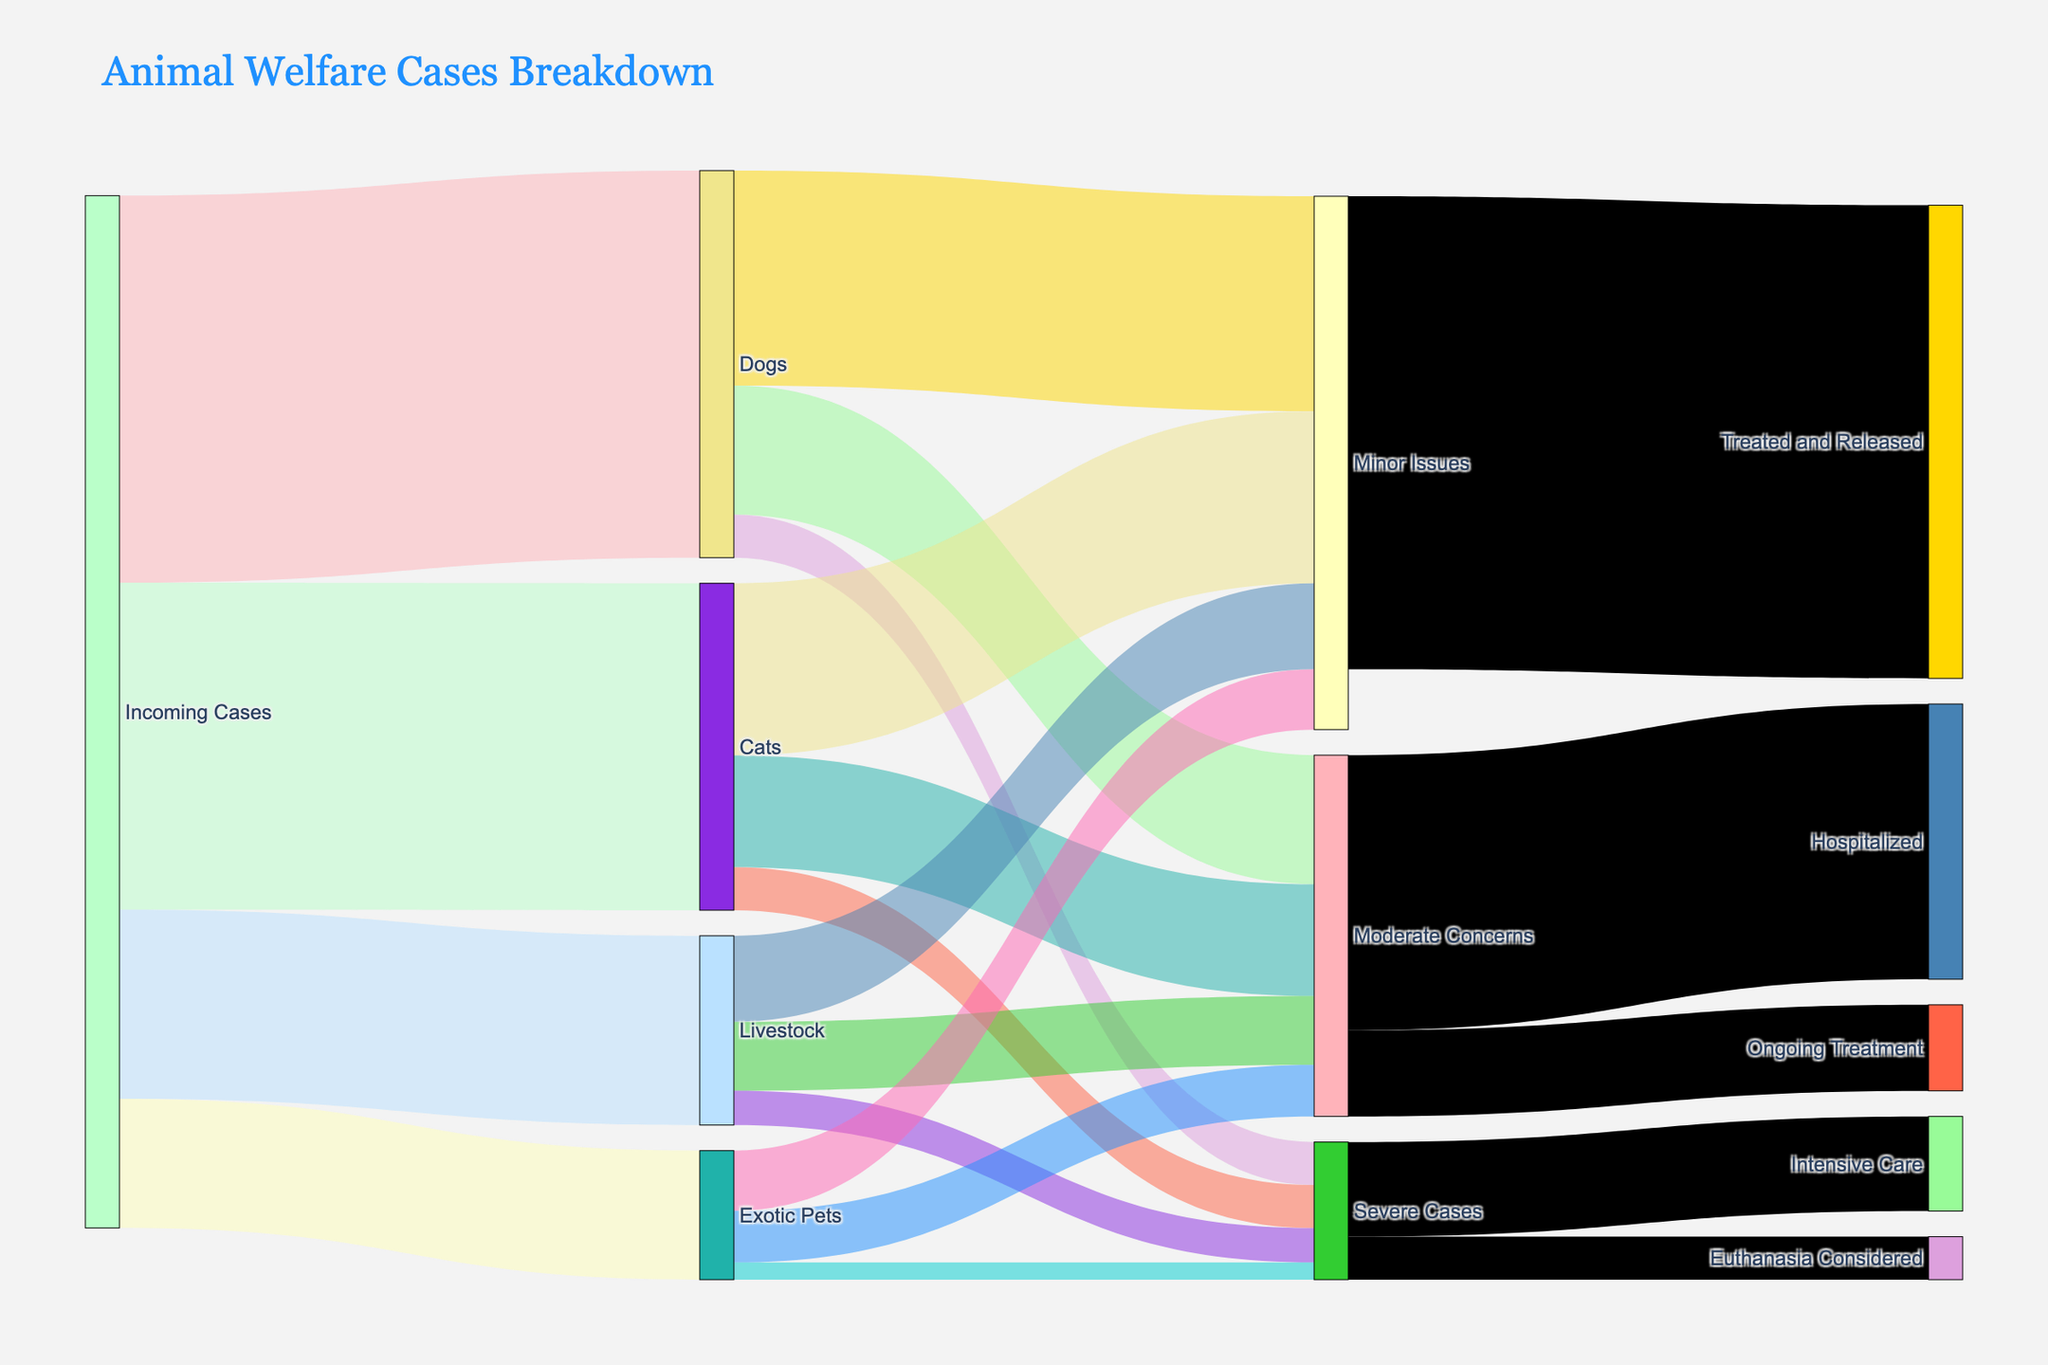How many incoming cases of dogs were handled by the veterinary clinic? To find the number of incoming cases of dogs, we look for the link connecting "Incoming Cases" to "Dogs" in the diagram, which shows a value of 450.
Answer: 450 What is the total number of cases classified as Minor Issues? Sum up the values for Minor Issues across all species: Dogs (250) + Cats (200) + Livestock (100) + Exotic Pets (70), which equals 620.
Answer: 620 Which species has the highest number of severe cases? Compare the numbers for Severe Cases across each species: Dogs (50), Cats (50), Livestock (40), Exotic Pets (20). Dogs and Cats have the highest number, 50 each.
Answer: Dogs and Cats Are more cases treated and released or hospitalized? Compare the values of "Treated and Released" (550) and "Hospitalized" (320). Treated and Released has a higher value.
Answer: Treated and Released What percentage of incoming Livestock cases were classified as Moderate Concerns? Divide the number of Moderate Concerns in Livestock (80) by the total incoming Livestock cases (220) and multiply by 100. \( \frac{80}{220} \times 100 \approx 36.36\%\)
Answer: 36.36% How many Severe Cases were considered for euthanasia? Look for the value connected to Severe Cases and "Euthanasia Considered," which shows 50.
Answer: 50 Which species has more Minor Issues: Dogs or Livestock? Compare the Minor Issues values for Dogs (250) and Livestock (100). Dogs have more Minor Issues.
Answer: Dogs What is the combined total of Moderate Concerns and Severe Cases? Add values for all species in both categories: Moderate Concerns (Dogs 150 + Cats 130 + Livestock 80 + Exotic Pets 60 = 420), and Severe Cases (Dogs 50 + Cats 50 + Livestock 40 + Exotic Pets 20 = 160). The combined total is 420 + 160 = 580.
Answer: 580 How many Minor Issues cases were treated and released? The diagram shows that 550 Minor Issues cases were treated and released.
Answer: 550 Which treatment path receives fewer cases, Ongoing Treatment or Intensive Care? Compare the values for Ongoing Treatment (100) and Intensive Care (110). Ongoing Treatment has fewer cases.
Answer: Ongoing Treatment 